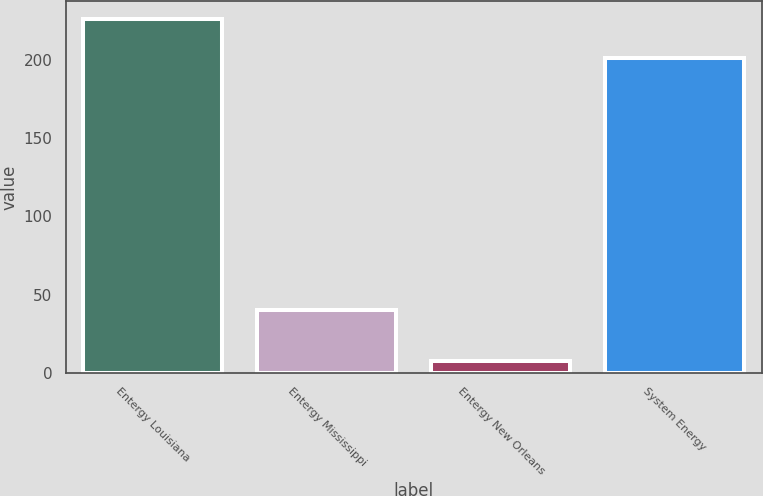Convert chart. <chart><loc_0><loc_0><loc_500><loc_500><bar_chart><fcel>Entergy Louisiana<fcel>Entergy Mississippi<fcel>Entergy New Orleans<fcel>System Energy<nl><fcel>226<fcel>40<fcel>7.3<fcel>200.8<nl></chart> 